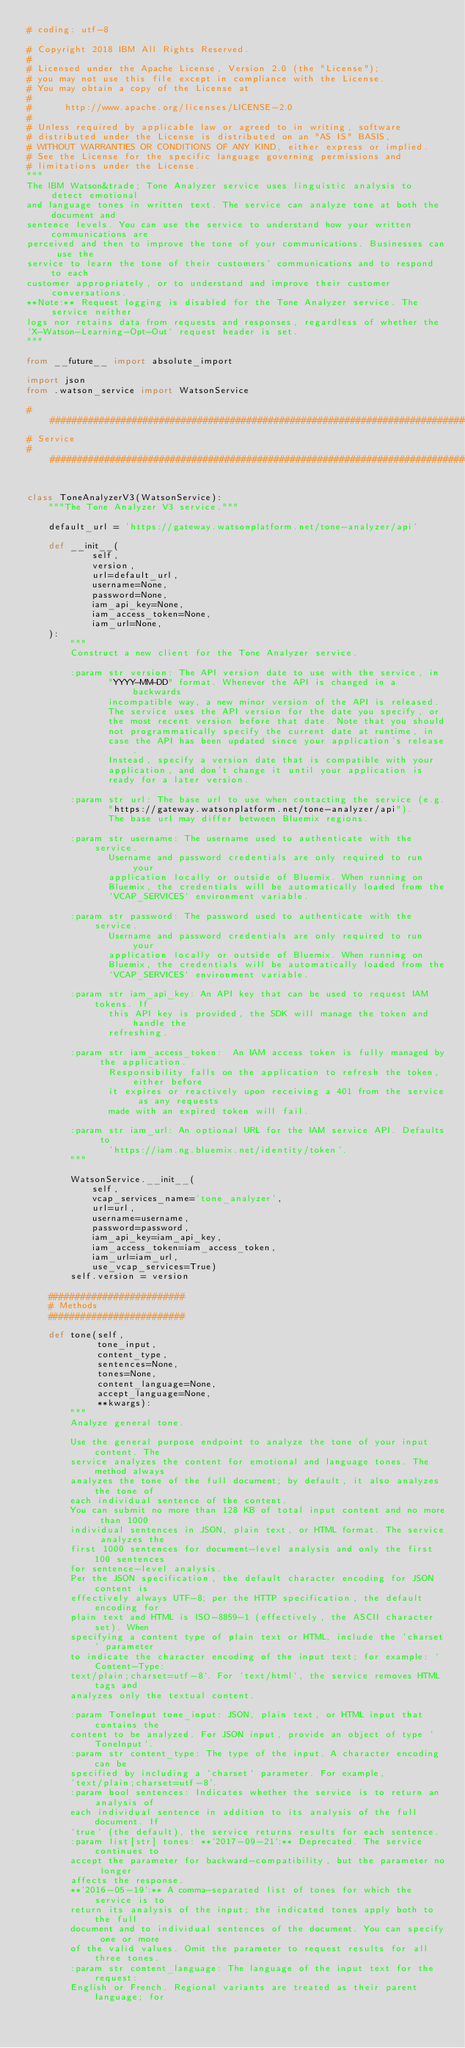<code> <loc_0><loc_0><loc_500><loc_500><_Python_># coding: utf-8

# Copyright 2018 IBM All Rights Reserved.
#
# Licensed under the Apache License, Version 2.0 (the "License");
# you may not use this file except in compliance with the License.
# You may obtain a copy of the License at
#
#      http://www.apache.org/licenses/LICENSE-2.0
#
# Unless required by applicable law or agreed to in writing, software
# distributed under the License is distributed on an "AS IS" BASIS,
# WITHOUT WARRANTIES OR CONDITIONS OF ANY KIND, either express or implied.
# See the License for the specific language governing permissions and
# limitations under the License.
"""
The IBM Watson&trade; Tone Analyzer service uses linguistic analysis to detect emotional
and language tones in written text. The service can analyze tone at both the document and
sentence levels. You can use the service to understand how your written communications are
perceived and then to improve the tone of your communications. Businesses can use the
service to learn the tone of their customers' communications and to respond to each
customer appropriately, or to understand and improve their customer conversations.
**Note:** Request logging is disabled for the Tone Analyzer service. The service neither
logs nor retains data from requests and responses, regardless of whether the
`X-Watson-Learning-Opt-Out` request header is set.
"""

from __future__ import absolute_import

import json
from .watson_service import WatsonService

##############################################################################
# Service
##############################################################################


class ToneAnalyzerV3(WatsonService):
    """The Tone Analyzer V3 service."""

    default_url = 'https://gateway.watsonplatform.net/tone-analyzer/api'

    def __init__(
            self,
            version,
            url=default_url,
            username=None,
            password=None,
            iam_api_key=None,
            iam_access_token=None,
            iam_url=None,
    ):
        """
        Construct a new client for the Tone Analyzer service.

        :param str version: The API version date to use with the service, in
               "YYYY-MM-DD" format. Whenever the API is changed in a backwards
               incompatible way, a new minor version of the API is released.
               The service uses the API version for the date you specify, or
               the most recent version before that date. Note that you should
               not programmatically specify the current date at runtime, in
               case the API has been updated since your application's release.
               Instead, specify a version date that is compatible with your
               application, and don't change it until your application is
               ready for a later version.

        :param str url: The base url to use when contacting the service (e.g.
               "https://gateway.watsonplatform.net/tone-analyzer/api").
               The base url may differ between Bluemix regions.

        :param str username: The username used to authenticate with the service.
               Username and password credentials are only required to run your
               application locally or outside of Bluemix. When running on
               Bluemix, the credentials will be automatically loaded from the
               `VCAP_SERVICES` environment variable.

        :param str password: The password used to authenticate with the service.
               Username and password credentials are only required to run your
               application locally or outside of Bluemix. When running on
               Bluemix, the credentials will be automatically loaded from the
               `VCAP_SERVICES` environment variable.

        :param str iam_api_key: An API key that can be used to request IAM tokens. If
               this API key is provided, the SDK will manage the token and handle the
               refreshing.

        :param str iam_access_token:  An IAM access token is fully managed by the application.
               Responsibility falls on the application to refresh the token, either before
               it expires or reactively upon receiving a 401 from the service as any requests
               made with an expired token will fail.

        :param str iam_url: An optional URL for the IAM service API. Defaults to
               'https://iam.ng.bluemix.net/identity/token'.
        """

        WatsonService.__init__(
            self,
            vcap_services_name='tone_analyzer',
            url=url,
            username=username,
            password=password,
            iam_api_key=iam_api_key,
            iam_access_token=iam_access_token,
            iam_url=iam_url,
            use_vcap_services=True)
        self.version = version

    #########################
    # Methods
    #########################

    def tone(self,
             tone_input,
             content_type,
             sentences=None,
             tones=None,
             content_language=None,
             accept_language=None,
             **kwargs):
        """
        Analyze general tone.

        Use the general purpose endpoint to analyze the tone of your input content. The
        service analyzes the content for emotional and language tones. The method always
        analyzes the tone of the full document; by default, it also analyzes the tone of
        each individual sentence of the content.
        You can submit no more than 128 KB of total input content and no more than 1000
        individual sentences in JSON, plain text, or HTML format. The service analyzes the
        first 1000 sentences for document-level analysis and only the first 100 sentences
        for sentence-level analysis.
        Per the JSON specification, the default character encoding for JSON content is
        effectively always UTF-8; per the HTTP specification, the default encoding for
        plain text and HTML is ISO-8859-1 (effectively, the ASCII character set). When
        specifying a content type of plain text or HTML, include the `charset` parameter
        to indicate the character encoding of the input text; for example: `Content-Type:
        text/plain;charset=utf-8`. For `text/html`, the service removes HTML tags and
        analyzes only the textual content.

        :param ToneInput tone_input: JSON, plain text, or HTML input that contains the
        content to be analyzed. For JSON input, provide an object of type `ToneInput`.
        :param str content_type: The type of the input. A character encoding can be
        specified by including a `charset` parameter. For example,
        'text/plain;charset=utf-8'.
        :param bool sentences: Indicates whether the service is to return an analysis of
        each individual sentence in addition to its analysis of the full document. If
        `true` (the default), the service returns results for each sentence.
        :param list[str] tones: **`2017-09-21`:** Deprecated. The service continues to
        accept the parameter for backward-compatibility, but the parameter no longer
        affects the response.
        **`2016-05-19`:** A comma-separated list of tones for which the service is to
        return its analysis of the input; the indicated tones apply both to the full
        document and to individual sentences of the document. You can specify one or more
        of the valid values. Omit the parameter to request results for all three tones.
        :param str content_language: The language of the input text for the request:
        English or French. Regional variants are treated as their parent language; for</code> 